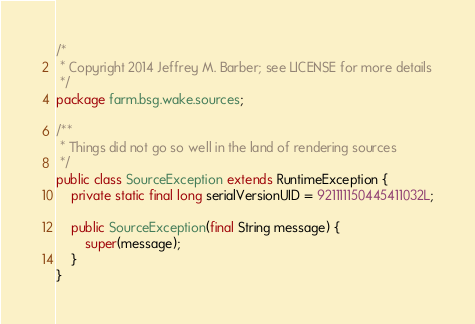Convert code to text. <code><loc_0><loc_0><loc_500><loc_500><_Java_>/*
 * Copyright 2014 Jeffrey M. Barber; see LICENSE for more details
 */
package farm.bsg.wake.sources;

/**
 * Things did not go so well in the land of rendering sources
 */
public class SourceException extends RuntimeException {
    private static final long serialVersionUID = 921111150445411032L;

    public SourceException(final String message) {
        super(message);
    }
}
</code> 